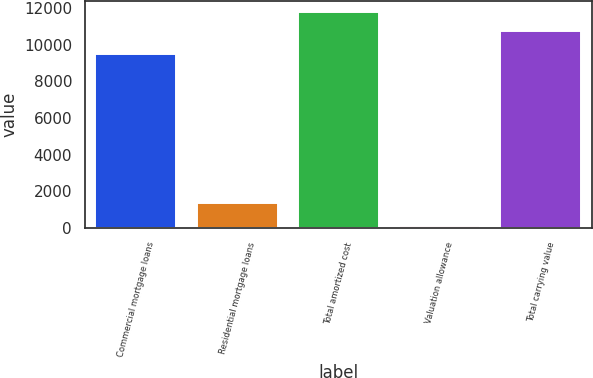<chart> <loc_0><loc_0><loc_500><loc_500><bar_chart><fcel>Commercial mortgage loans<fcel>Residential mortgage loans<fcel>Total amortized cost<fcel>Valuation allowance<fcel>Total carrying value<nl><fcel>9461.4<fcel>1367.9<fcel>11799.9<fcel>102.1<fcel>10727.2<nl></chart> 